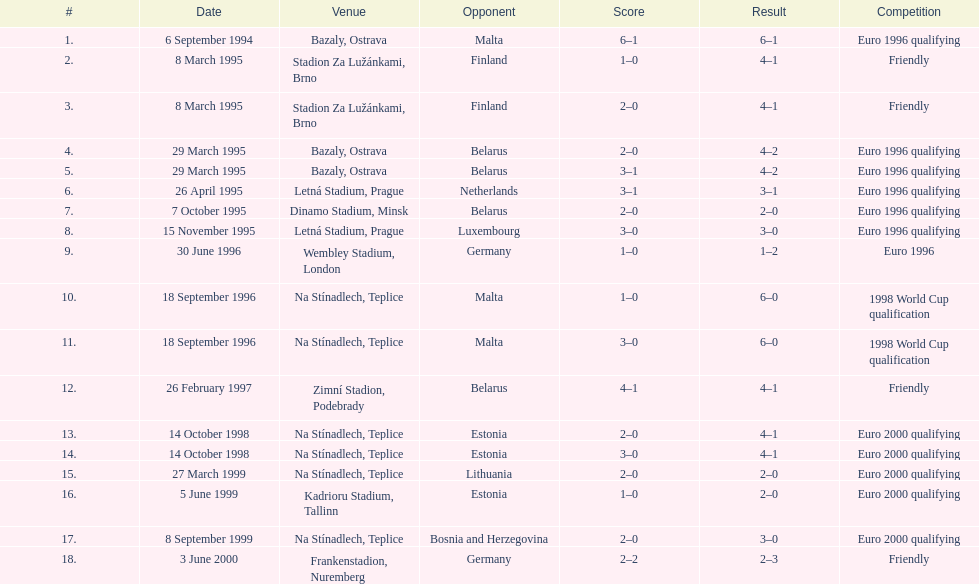In the table, which competitor is positioned last? Germany. 